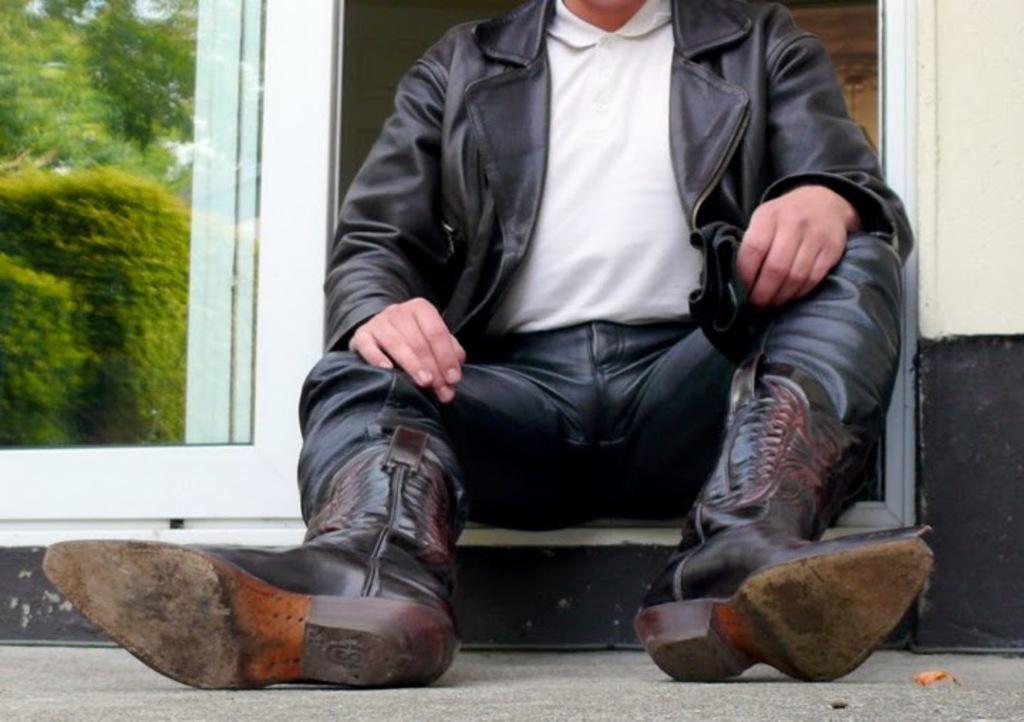How would you summarize this image in a sentence or two? In this image we can see a person. We can see the reflection of trees on the glass at the left side of the image. 